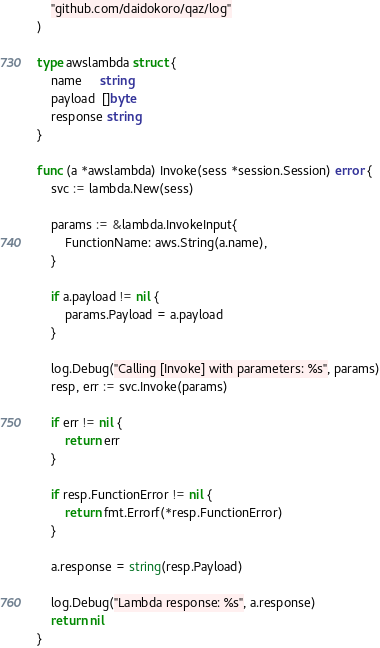Convert code to text. <code><loc_0><loc_0><loc_500><loc_500><_Go_>	"github.com/daidokoro/qaz/log"
)

type awslambda struct {
	name     string
	payload  []byte
	response string
}

func (a *awslambda) Invoke(sess *session.Session) error {
	svc := lambda.New(sess)

	params := &lambda.InvokeInput{
		FunctionName: aws.String(a.name),
	}

	if a.payload != nil {
		params.Payload = a.payload
	}

	log.Debug("Calling [Invoke] with parameters: %s", params)
	resp, err := svc.Invoke(params)

	if err != nil {
		return err
	}

	if resp.FunctionError != nil {
		return fmt.Errorf(*resp.FunctionError)
	}

	a.response = string(resp.Payload)

	log.Debug("Lambda response: %s", a.response)
	return nil
}
</code> 